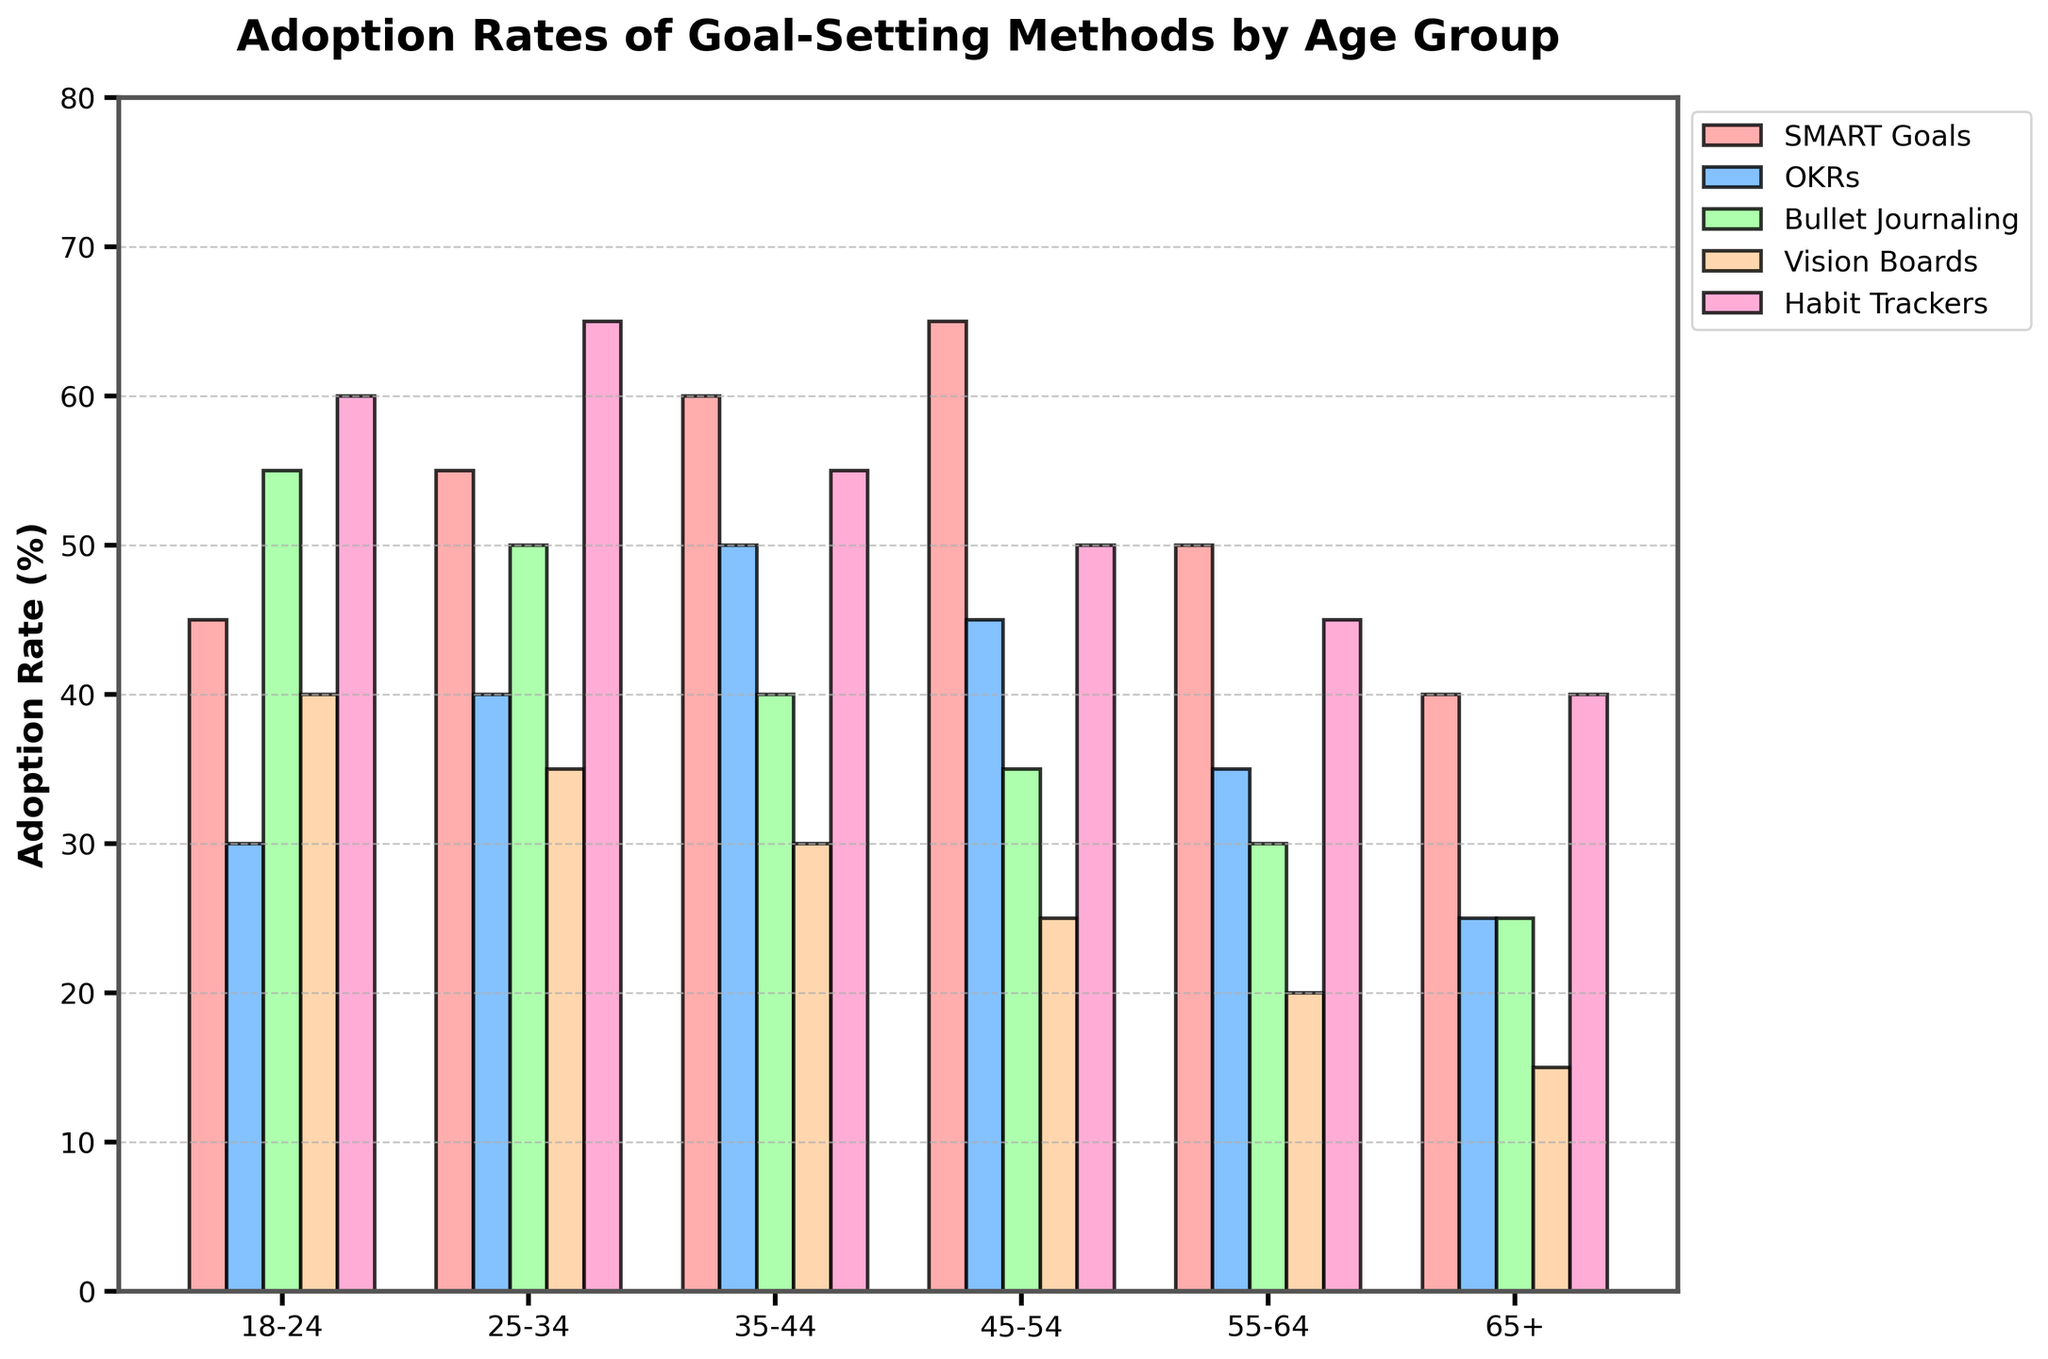What's the most adopted goal-setting method among the 18-24 age group? The bar representing Habit Trackers is the tallest for the 18-24 age group. It shows an adoption rate of 60%, which is higher than any other method within this age group.
Answer: Habit Trackers Which age group has the lowest adoption rate for Vision Boards? The bar for Vision Boards is the shortest for the 65+ age group, indicating the lowest adoption rate.
Answer: 65+ What is the average adoption rate of OKRs across all age groups? To find the average adoption rate, add up all adoption rates of OKRs for each age group and divide by the number of age groups: (30 + 40 + 50 + 45 + 35 + 25) / 6 = 225/6.
Answer: 37.5 Is the adoption rate of Bullet Journaling higher or lower in the 18-24 age group compared to the 35-44 age group? Comparing the heights of the bars for Bullet Journaling, the 18-24 age group has a higher adoption rate (55%) compared to the 35-44 age group (40%).
Answer: Higher What is the total adoption rate of SMART Goals for all age groups combined? To find the total adoption rate of SMART Goals, sum the values across all age groups: 45 + 55 + 60 + 65 + 50 + 40 = 315.
Answer: 315 Which age group shows the greatest diversity in adoption rates among the different methods? The 65+ age group shows the greatest diversity: the highest adoption rate (Habit Trackers at 40%) and the lowest (Vision Boards at 15%), giving a range of 25%.
Answer: 65+ For the 25-34 age group, what is the difference between the adoption rates of Habit Trackers and Vision Boards? The adoption rates of Habit Trackers and Vision Boards in the 25-34 age group are 65% and 35%, respectively. The difference is calculated as 65 - 35.
Answer: 30 Which goal-setting method has a consistent decline in adoption rates as the age group increases? Vision Boards have a consistent decline in adoption rates from 40% in the 18-24 age group to 15% in the 65+ age group.
Answer: Vision Boards What is the sum of the highest adoption rates for all methods across all age groups? The highest adoption rates for each method across all age groups are: SMART Goals (65%), OKRs (50%), Bullet Journaling (55%), Vision Boards (40%), and Habit Trackers (65%). Adding these values gives 65 + 50 + 55 + 40 + 65 = 275.
Answer: 275 